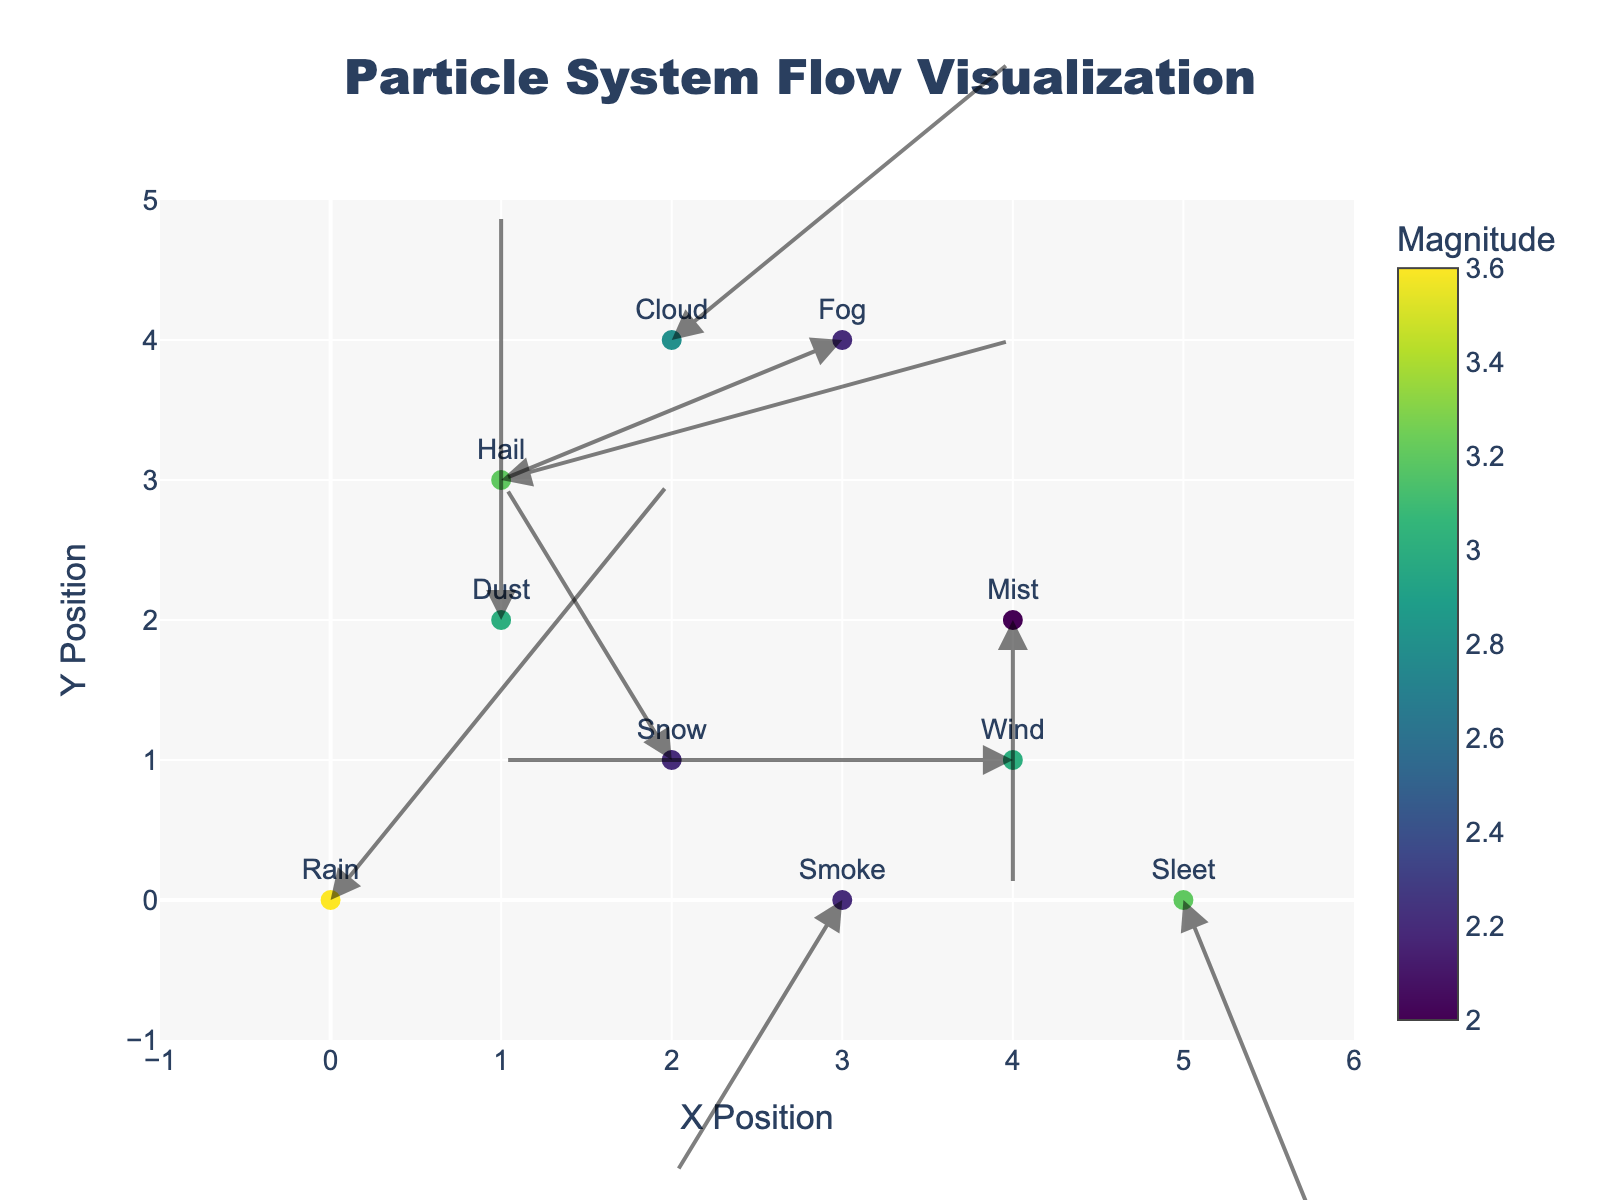What is the highest magnitude color on the color scale? The color scale represents magnitude, and the highest color should correspond to the maximum magnitude value displayed on the figure, which is 3.6 for Rain.
Answer: 3.6 How many particle types are represented in the figure? Each unique text label on the scatter plot represents a different particle type. You can count the labels (Rain, Snow, Mist, Hail, Fog, Sleet, Cloud, Wind, Dust, Smoke).
Answer: 10 Which particle types show a downward flow in the y-direction? Compare the arrows' directions in the figure. Downward flow corresponds to negative y-component 'v'. Check the particles with negative 'v': Mist, Sleet, and Smoke.
Answer: Mist, Sleet, Smoke What is the total magnitude of particles flowing leftwards (negative x-direction)? Identify particles with u < 0: Snow (2.2), Fog (2.2), Wind (3.0), Smoke (2.2). Sum these magnitudes: 2.2 + 2.2 + 3.0 + 2.2
Answer: 9.6 Which particle type has the longest vector and what is its magnitude and direction? The vector magnitude can be identified by the color scale and the magnitude values. Rain has the highest magnitude (3.6). Direction can be inferred from the arrow orientation (mostly upwards).
Answer: Rain, 3.6, upwards Are any two particle types in the same y-position with different x-directions? Find particles with the same 'y' but different 'x' and opposite 'u' values. Cloud (2,4) and Fog (3,4) both are at y=4 but Cloud moves right while Fog moves left.
Answer: Yes, Cloud and Fog Which particle type has both the smallest x and y movements? Check the u and v components: Mist has (0, -2), only moving vertically, compared to others which have non-zero x movement.
Answer: Mist What types of weather effects are closest to the center of the plot? The center of the plot can be considered around (2.5, 2.5). Check for particles near this point: Snow (2,1), Hail (1,3), Cloud (2,4), Wind (4,1).
Answer: Snow, Hail, Cloud, Wind 